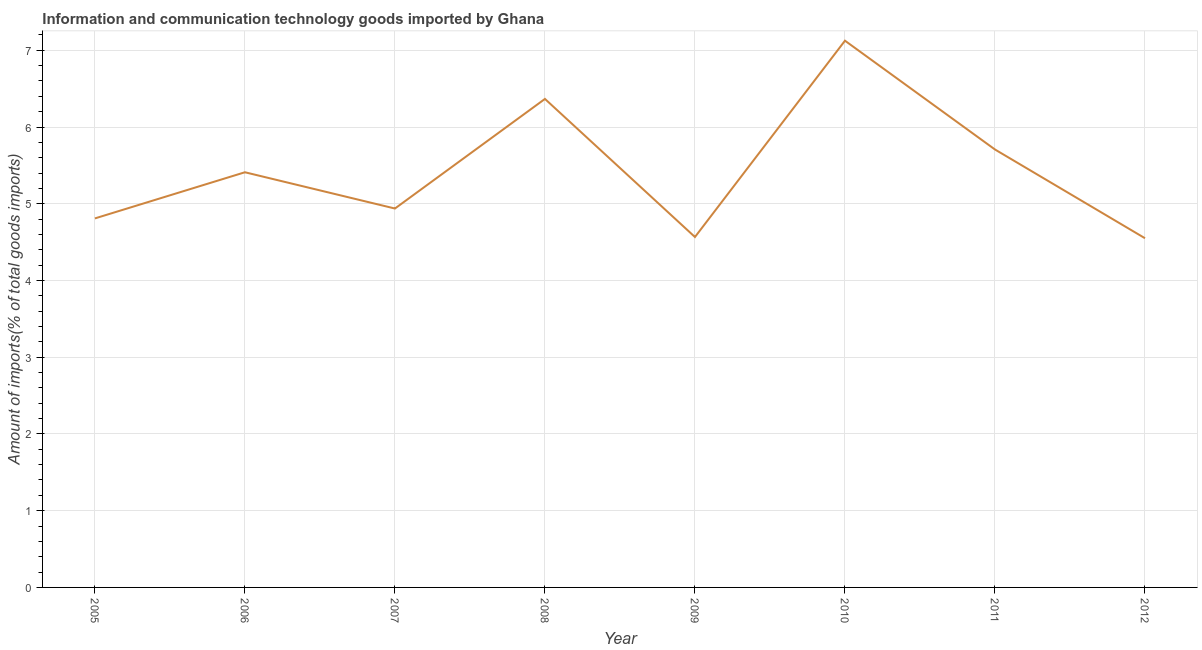What is the amount of ict goods imports in 2008?
Give a very brief answer. 6.37. Across all years, what is the maximum amount of ict goods imports?
Your response must be concise. 7.13. Across all years, what is the minimum amount of ict goods imports?
Ensure brevity in your answer.  4.55. In which year was the amount of ict goods imports maximum?
Your answer should be very brief. 2010. In which year was the amount of ict goods imports minimum?
Keep it short and to the point. 2012. What is the sum of the amount of ict goods imports?
Your response must be concise. 43.47. What is the difference between the amount of ict goods imports in 2010 and 2011?
Make the answer very short. 1.42. What is the average amount of ict goods imports per year?
Give a very brief answer. 5.43. What is the median amount of ict goods imports?
Make the answer very short. 5.17. What is the ratio of the amount of ict goods imports in 2005 to that in 2012?
Provide a short and direct response. 1.06. Is the amount of ict goods imports in 2005 less than that in 2006?
Ensure brevity in your answer.  Yes. What is the difference between the highest and the second highest amount of ict goods imports?
Your response must be concise. 0.76. Is the sum of the amount of ict goods imports in 2005 and 2008 greater than the maximum amount of ict goods imports across all years?
Your answer should be very brief. Yes. What is the difference between the highest and the lowest amount of ict goods imports?
Provide a succinct answer. 2.57. In how many years, is the amount of ict goods imports greater than the average amount of ict goods imports taken over all years?
Offer a terse response. 3. How many lines are there?
Your answer should be very brief. 1. How many years are there in the graph?
Offer a very short reply. 8. Does the graph contain any zero values?
Give a very brief answer. No. What is the title of the graph?
Your answer should be compact. Information and communication technology goods imported by Ghana. What is the label or title of the X-axis?
Provide a short and direct response. Year. What is the label or title of the Y-axis?
Your response must be concise. Amount of imports(% of total goods imports). What is the Amount of imports(% of total goods imports) in 2005?
Make the answer very short. 4.81. What is the Amount of imports(% of total goods imports) in 2006?
Provide a succinct answer. 5.41. What is the Amount of imports(% of total goods imports) of 2007?
Your answer should be very brief. 4.94. What is the Amount of imports(% of total goods imports) of 2008?
Provide a succinct answer. 6.37. What is the Amount of imports(% of total goods imports) in 2009?
Offer a very short reply. 4.57. What is the Amount of imports(% of total goods imports) of 2010?
Provide a short and direct response. 7.13. What is the Amount of imports(% of total goods imports) in 2011?
Provide a short and direct response. 5.71. What is the Amount of imports(% of total goods imports) in 2012?
Your answer should be very brief. 4.55. What is the difference between the Amount of imports(% of total goods imports) in 2005 and 2006?
Offer a terse response. -0.6. What is the difference between the Amount of imports(% of total goods imports) in 2005 and 2007?
Offer a very short reply. -0.13. What is the difference between the Amount of imports(% of total goods imports) in 2005 and 2008?
Offer a very short reply. -1.56. What is the difference between the Amount of imports(% of total goods imports) in 2005 and 2009?
Ensure brevity in your answer.  0.24. What is the difference between the Amount of imports(% of total goods imports) in 2005 and 2010?
Your answer should be compact. -2.32. What is the difference between the Amount of imports(% of total goods imports) in 2005 and 2011?
Provide a succinct answer. -0.9. What is the difference between the Amount of imports(% of total goods imports) in 2005 and 2012?
Your answer should be compact. 0.26. What is the difference between the Amount of imports(% of total goods imports) in 2006 and 2007?
Offer a very short reply. 0.47. What is the difference between the Amount of imports(% of total goods imports) in 2006 and 2008?
Your answer should be very brief. -0.96. What is the difference between the Amount of imports(% of total goods imports) in 2006 and 2009?
Your answer should be compact. 0.84. What is the difference between the Amount of imports(% of total goods imports) in 2006 and 2010?
Make the answer very short. -1.71. What is the difference between the Amount of imports(% of total goods imports) in 2006 and 2011?
Make the answer very short. -0.3. What is the difference between the Amount of imports(% of total goods imports) in 2006 and 2012?
Offer a very short reply. 0.86. What is the difference between the Amount of imports(% of total goods imports) in 2007 and 2008?
Keep it short and to the point. -1.43. What is the difference between the Amount of imports(% of total goods imports) in 2007 and 2009?
Your answer should be very brief. 0.37. What is the difference between the Amount of imports(% of total goods imports) in 2007 and 2010?
Provide a short and direct response. -2.19. What is the difference between the Amount of imports(% of total goods imports) in 2007 and 2011?
Offer a very short reply. -0.77. What is the difference between the Amount of imports(% of total goods imports) in 2007 and 2012?
Offer a very short reply. 0.39. What is the difference between the Amount of imports(% of total goods imports) in 2008 and 2009?
Give a very brief answer. 1.8. What is the difference between the Amount of imports(% of total goods imports) in 2008 and 2010?
Offer a terse response. -0.76. What is the difference between the Amount of imports(% of total goods imports) in 2008 and 2011?
Provide a succinct answer. 0.66. What is the difference between the Amount of imports(% of total goods imports) in 2008 and 2012?
Your answer should be compact. 1.82. What is the difference between the Amount of imports(% of total goods imports) in 2009 and 2010?
Provide a succinct answer. -2.56. What is the difference between the Amount of imports(% of total goods imports) in 2009 and 2011?
Your response must be concise. -1.14. What is the difference between the Amount of imports(% of total goods imports) in 2009 and 2012?
Your answer should be compact. 0.02. What is the difference between the Amount of imports(% of total goods imports) in 2010 and 2011?
Your answer should be compact. 1.42. What is the difference between the Amount of imports(% of total goods imports) in 2010 and 2012?
Provide a succinct answer. 2.57. What is the difference between the Amount of imports(% of total goods imports) in 2011 and 2012?
Your response must be concise. 1.16. What is the ratio of the Amount of imports(% of total goods imports) in 2005 to that in 2006?
Your answer should be very brief. 0.89. What is the ratio of the Amount of imports(% of total goods imports) in 2005 to that in 2007?
Offer a very short reply. 0.97. What is the ratio of the Amount of imports(% of total goods imports) in 2005 to that in 2008?
Your answer should be compact. 0.76. What is the ratio of the Amount of imports(% of total goods imports) in 2005 to that in 2009?
Your answer should be compact. 1.05. What is the ratio of the Amount of imports(% of total goods imports) in 2005 to that in 2010?
Keep it short and to the point. 0.68. What is the ratio of the Amount of imports(% of total goods imports) in 2005 to that in 2011?
Make the answer very short. 0.84. What is the ratio of the Amount of imports(% of total goods imports) in 2005 to that in 2012?
Provide a short and direct response. 1.06. What is the ratio of the Amount of imports(% of total goods imports) in 2006 to that in 2007?
Your response must be concise. 1.1. What is the ratio of the Amount of imports(% of total goods imports) in 2006 to that in 2009?
Provide a succinct answer. 1.19. What is the ratio of the Amount of imports(% of total goods imports) in 2006 to that in 2010?
Keep it short and to the point. 0.76. What is the ratio of the Amount of imports(% of total goods imports) in 2006 to that in 2011?
Your answer should be compact. 0.95. What is the ratio of the Amount of imports(% of total goods imports) in 2006 to that in 2012?
Keep it short and to the point. 1.19. What is the ratio of the Amount of imports(% of total goods imports) in 2007 to that in 2008?
Provide a short and direct response. 0.78. What is the ratio of the Amount of imports(% of total goods imports) in 2007 to that in 2009?
Ensure brevity in your answer.  1.08. What is the ratio of the Amount of imports(% of total goods imports) in 2007 to that in 2010?
Ensure brevity in your answer.  0.69. What is the ratio of the Amount of imports(% of total goods imports) in 2007 to that in 2011?
Offer a very short reply. 0.86. What is the ratio of the Amount of imports(% of total goods imports) in 2007 to that in 2012?
Provide a succinct answer. 1.08. What is the ratio of the Amount of imports(% of total goods imports) in 2008 to that in 2009?
Your response must be concise. 1.39. What is the ratio of the Amount of imports(% of total goods imports) in 2008 to that in 2010?
Offer a very short reply. 0.89. What is the ratio of the Amount of imports(% of total goods imports) in 2008 to that in 2011?
Your answer should be very brief. 1.11. What is the ratio of the Amount of imports(% of total goods imports) in 2008 to that in 2012?
Make the answer very short. 1.4. What is the ratio of the Amount of imports(% of total goods imports) in 2009 to that in 2010?
Your response must be concise. 0.64. What is the ratio of the Amount of imports(% of total goods imports) in 2009 to that in 2011?
Your answer should be very brief. 0.8. What is the ratio of the Amount of imports(% of total goods imports) in 2009 to that in 2012?
Your response must be concise. 1. What is the ratio of the Amount of imports(% of total goods imports) in 2010 to that in 2011?
Provide a succinct answer. 1.25. What is the ratio of the Amount of imports(% of total goods imports) in 2010 to that in 2012?
Offer a very short reply. 1.57. What is the ratio of the Amount of imports(% of total goods imports) in 2011 to that in 2012?
Make the answer very short. 1.25. 